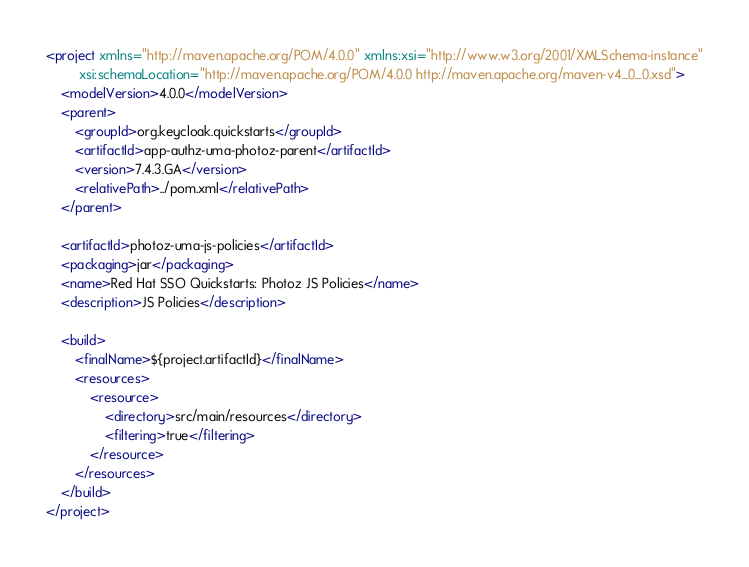Convert code to text. <code><loc_0><loc_0><loc_500><loc_500><_XML_><project xmlns="http://maven.apache.org/POM/4.0.0" xmlns:xsi="http://www.w3.org/2001/XMLSchema-instance"
         xsi:schemaLocation="http://maven.apache.org/POM/4.0.0 http://maven.apache.org/maven-v4_0_0.xsd">
    <modelVersion>4.0.0</modelVersion>
    <parent>
        <groupId>org.keycloak.quickstarts</groupId>
        <artifactId>app-authz-uma-photoz-parent</artifactId>
        <version>7.4.3.GA</version>
        <relativePath>../pom.xml</relativePath>
    </parent>

    <artifactId>photoz-uma-js-policies</artifactId>
    <packaging>jar</packaging>
    <name>Red Hat SSO Quickstarts: Photoz JS Policies</name>
    <description>JS Policies</description>

    <build>
        <finalName>${project.artifactId}</finalName>
        <resources>
            <resource>
                <directory>src/main/resources</directory>
                <filtering>true</filtering>
            </resource>
        </resources>
    </build>
</project>
</code> 